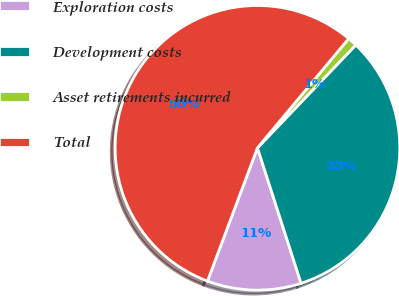Convert chart to OTSL. <chart><loc_0><loc_0><loc_500><loc_500><pie_chart><fcel>Exploration costs<fcel>Development costs<fcel>Asset retirements incurred<fcel>Total<nl><fcel>10.67%<fcel>32.9%<fcel>1.07%<fcel>55.36%<nl></chart> 